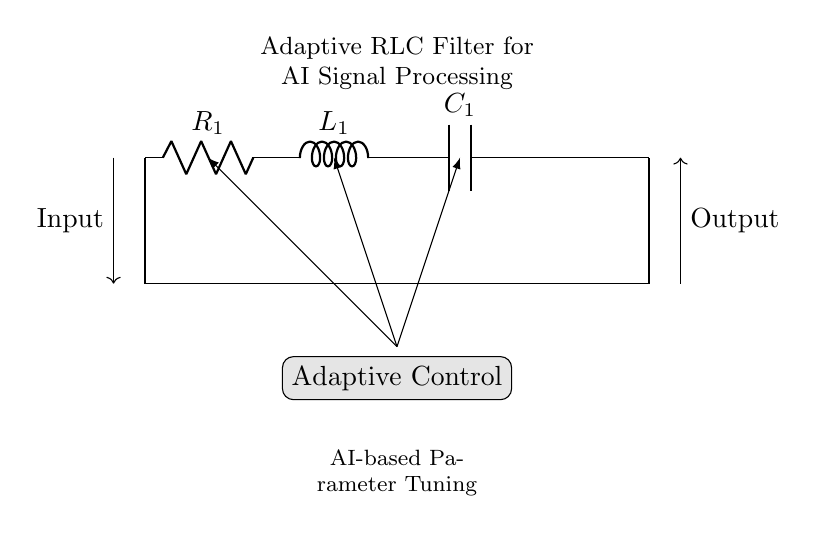What components are present in the circuit? The circuit contains a resistor, inductor, and capacitor, which are the primary components typically found in an RLC filter. The labels indicate these components as R for the resistor, L for the inductor, and C for the capacitor.
Answer: Resistor, inductor, capacitor What is the purpose of the adaptive control in this circuit? The adaptive control is utilized for adjusting the circuit parameters, such as resistance, inductance, and capacitance, in relation to the input signal characteristics. This allows the RLC filter to adapt to varying conditions effectively, improving its performance in AI signal processing.
Answer: Parameter adjustment What is the input direction in the circuit? The input direction indicated by the arrow is coming from the left side of the circuit. The arrow shows that the signal is entering the circuit through the input terminal.
Answer: From the left What does the output of the circuit point towards? The output, indicated by the arrow, points to the right side of the circuit, meaning the processed signal exits towards that direction after passing through the filter components.
Answer: To the right What type of filter is represented by this circuit? This circuit represents an adaptive RLC filter, which combines the properties of resistors, inductors, and capacitors to filter signals adaptively based on AI parameter tuning methods.
Answer: Adaptive RLC filter How does the AI-based parameter tuning operate in this circuit? The AI-based parameter tuning adjusts the values of R, L, and C dynamically based on signal characteristics for enhanced filtering performance, ensuring optimal response to varying inputs. This can improve noise reduction and signal clarity.
Answer: Dynamic adjustment What is the significance of the circuit connections between the components? The connections between the resistor, inductor, and capacitor form a series configuration, which is pivotal in creating the desired filter characteristics such as resonance frequency and damping behavior. This arrangement significantly influences the circuit's response to different frequencies.
Answer: Series configuration 